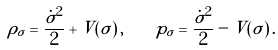<formula> <loc_0><loc_0><loc_500><loc_500>\rho _ { \sigma } = \frac { \dot { \sigma } ^ { 2 } } { 2 } + V ( \sigma ) \, , \quad p _ { \sigma } = \frac { \dot { \sigma } ^ { 2 } } { 2 } - V ( \sigma ) \, .</formula> 